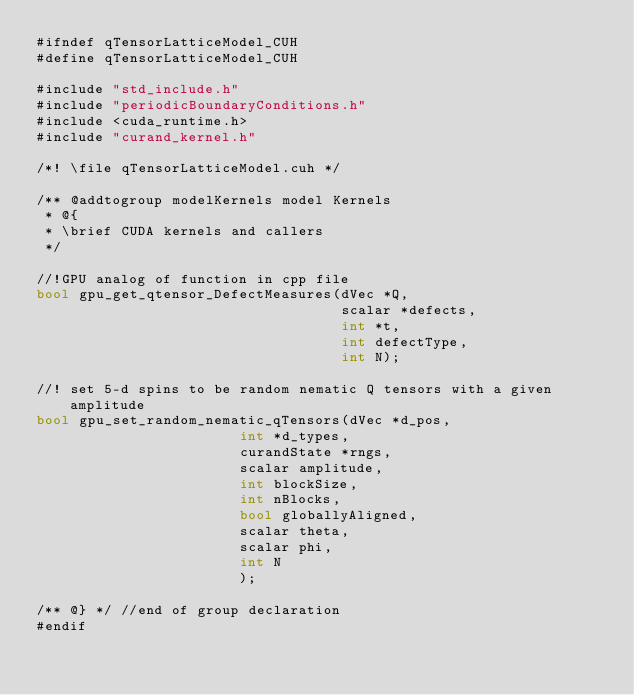Convert code to text. <code><loc_0><loc_0><loc_500><loc_500><_Cuda_>#ifndef qTensorLatticeModel_CUH
#define qTensorLatticeModel_CUH

#include "std_include.h"
#include "periodicBoundaryConditions.h"
#include <cuda_runtime.h>
#include "curand_kernel.h"

/*! \file qTensorLatticeModel.cuh */

/** @addtogroup modelKernels model Kernels
 * @{
 * \brief CUDA kernels and callers
 */

//!GPU analog of function in cpp file
bool gpu_get_qtensor_DefectMeasures(dVec *Q,
                                    scalar *defects,
                                    int *t,
                                    int defectType,
                                    int N);

//! set 5-d spins to be random nematic Q tensors with a given amplitude
bool gpu_set_random_nematic_qTensors(dVec *d_pos,
                        int *d_types,
                        curandState *rngs,
                        scalar amplitude,
                        int blockSize,
                        int nBlocks,
                        bool globallyAligned,
                        scalar theta,
                        scalar phi,
                        int N
                        );

/** @} */ //end of group declaration
#endif
</code> 